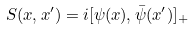<formula> <loc_0><loc_0><loc_500><loc_500>S ( x , x ^ { \prime } ) = i [ \psi ( x ) , \bar { \psi } ( x ^ { \prime } ) ] _ { + }</formula> 